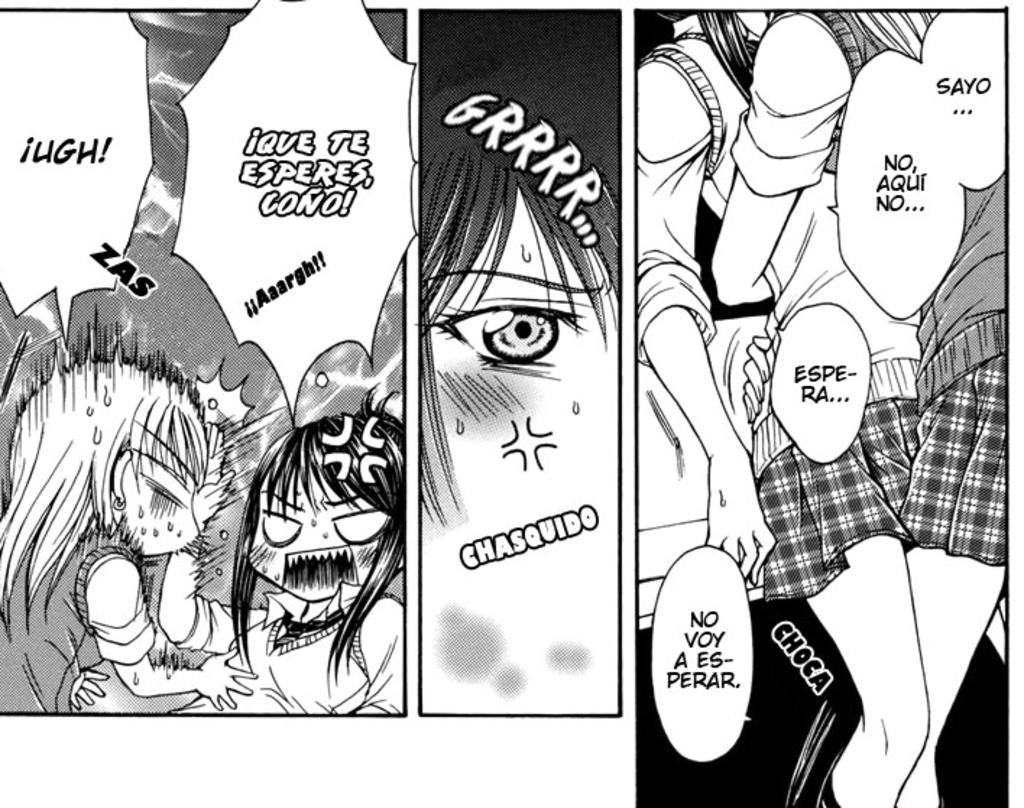What type of image is being described? The image is a black and white animated picture. Are there any words or phrases written in the image? Yes, there is text written in the image. What type of animal can be seen in the house in the image? There is no animal or house present in the image; it is a black and white animated picture with text. What is the value of the item being depicted in the image? The image does not depict any item with a specific value; it is a black and white animated picture with text. 